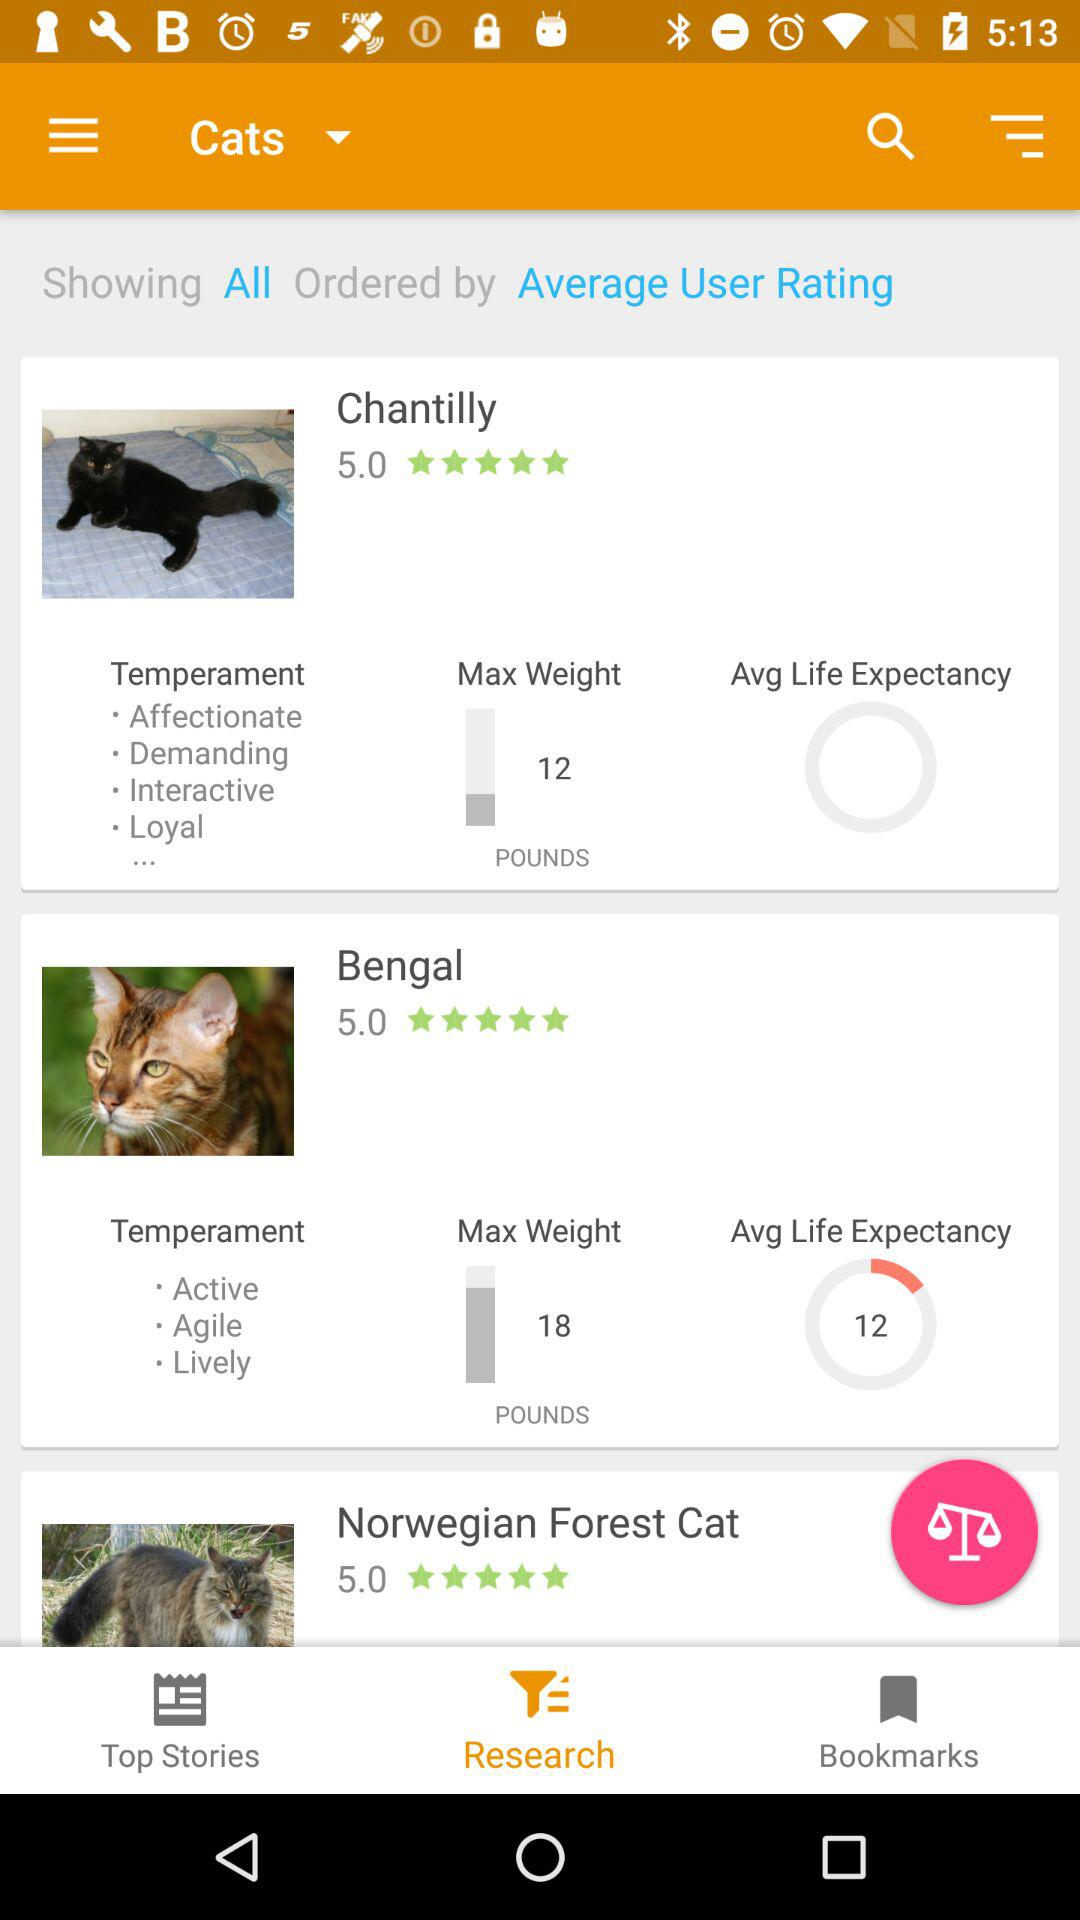What is the rating of Bengal? The rating is 5.0. 